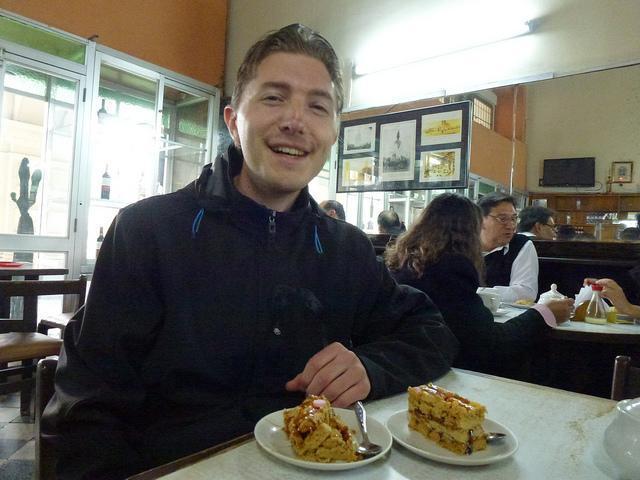How many plates in front of the man?
Give a very brief answer. 2. How many cakes can you see?
Give a very brief answer. 2. How many people can you see?
Give a very brief answer. 3. How many cows are to the left of the person in the middle?
Give a very brief answer. 0. 